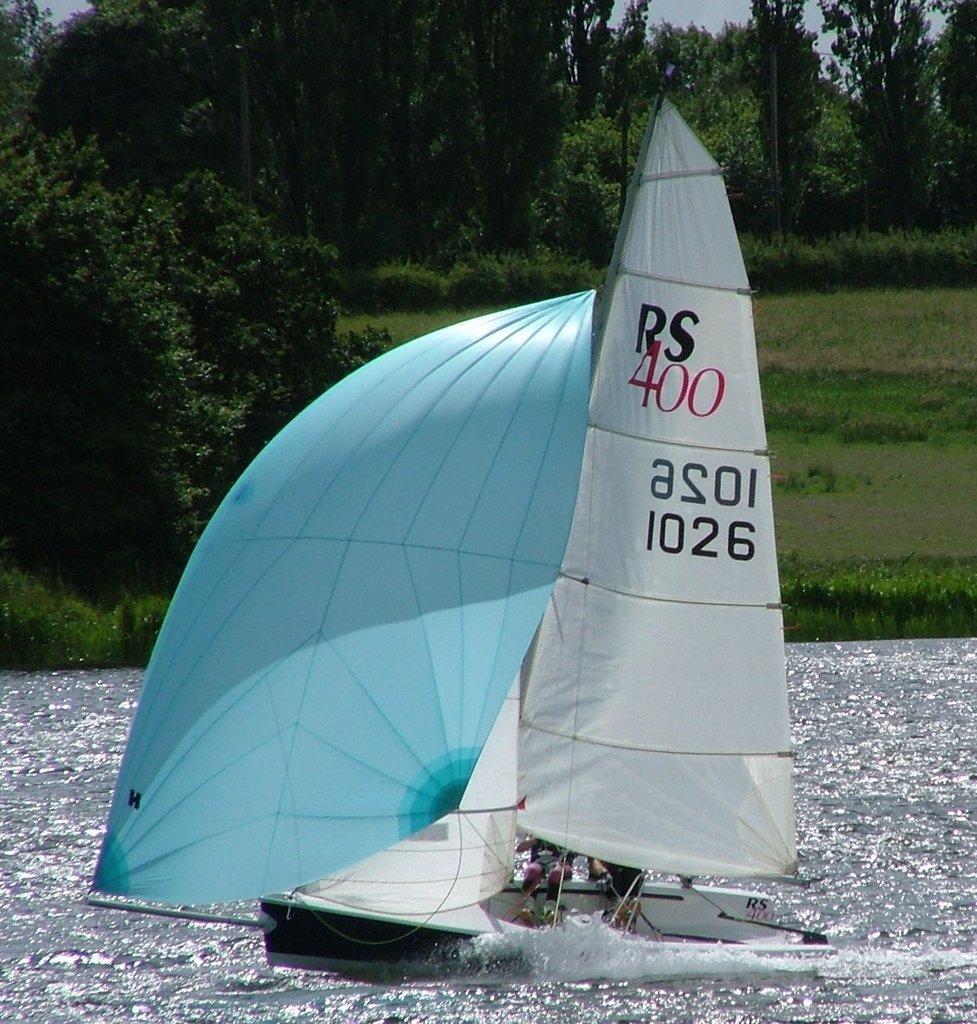Can you describe this image briefly? In the center of the image we can see a boat and also we can see two persons. In the background of the image we can see trees, grass, groundwater. At the top of the image we can see the sky. 